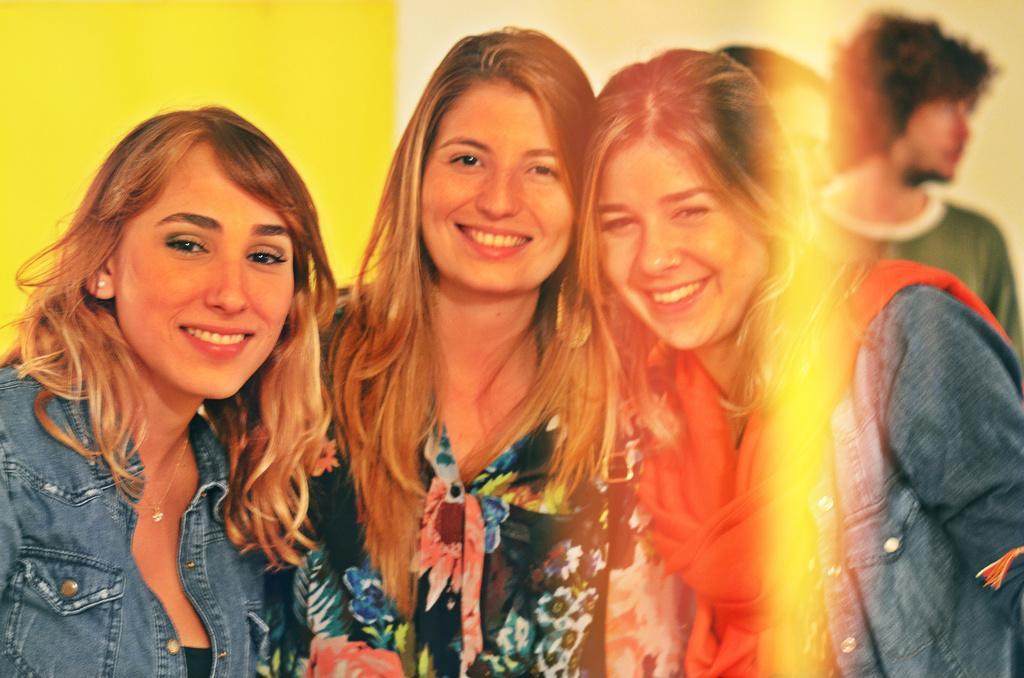Describe this image in one or two sentences. There are three women standing and smiling. This looks like an edited image. In the background, I can see two people standing. I think this is the wall, which is yellow in color. 